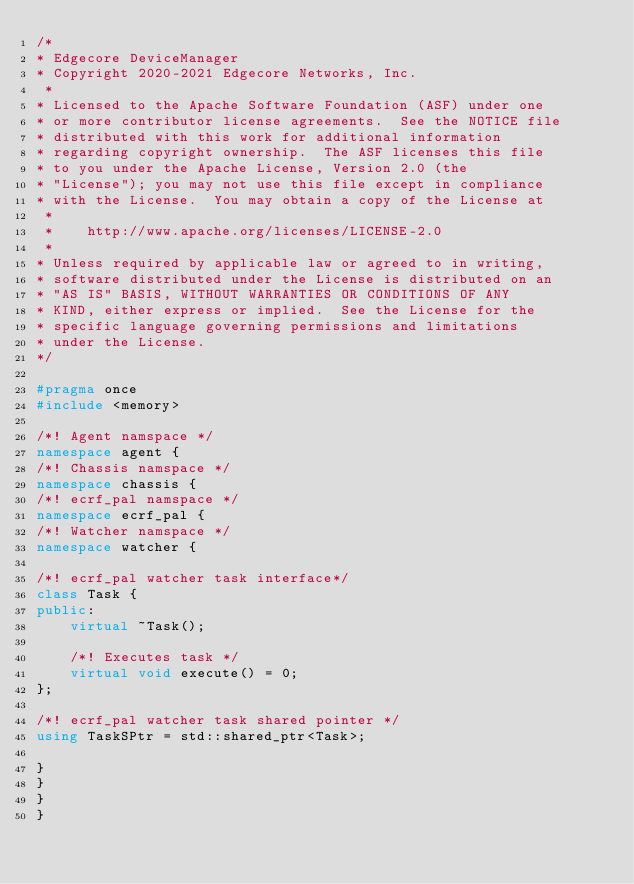Convert code to text. <code><loc_0><loc_0><loc_500><loc_500><_C++_>/*
* Edgecore DeviceManager
* Copyright 2020-2021 Edgecore Networks, Inc.
 *
* Licensed to the Apache Software Foundation (ASF) under one
* or more contributor license agreements.  See the NOTICE file
* distributed with this work for additional information
* regarding copyright ownership.  The ASF licenses this file
* to you under the Apache License, Version 2.0 (the
* "License"); you may not use this file except in compliance
* with the License.  You may obtain a copy of the License at
 *
 *    http://www.apache.org/licenses/LICENSE-2.0
 *
* Unless required by applicable law or agreed to in writing,
* software distributed under the License is distributed on an
* "AS IS" BASIS, WITHOUT WARRANTIES OR CONDITIONS OF ANY
* KIND, either express or implied.  See the License for the
* specific language governing permissions and limitations
* under the License.
*/

#pragma once
#include <memory>

/*! Agent namspace */
namespace agent {
/*! Chassis namspace */
namespace chassis {
/*! ecrf_pal namspace */
namespace ecrf_pal {
/*! Watcher namspace */
namespace watcher {

/*! ecrf_pal watcher task interface*/
class Task {
public:
    virtual ~Task();

    /*! Executes task */
    virtual void execute() = 0;
};

/*! ecrf_pal watcher task shared pointer */
using TaskSPtr = std::shared_ptr<Task>;

}
}
}
}

</code> 